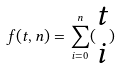Convert formula to latex. <formula><loc_0><loc_0><loc_500><loc_500>f ( t , n ) = \sum _ { i = 0 } ^ { n } ( \begin{matrix} t \\ i \end{matrix} )</formula> 